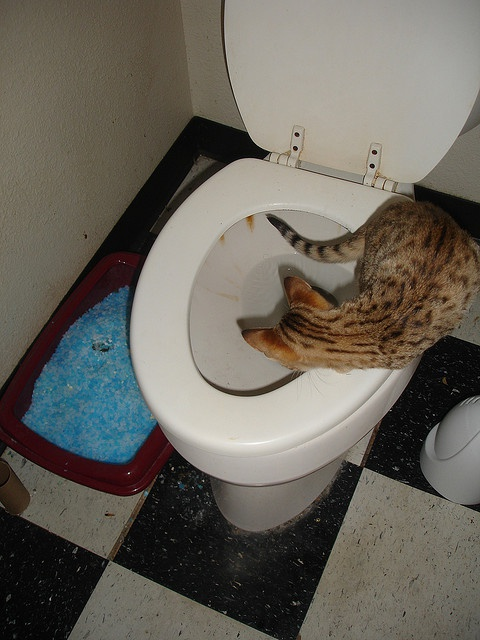Describe the objects in this image and their specific colors. I can see toilet in gray, darkgray, and lightgray tones and cat in gray, maroon, and black tones in this image. 